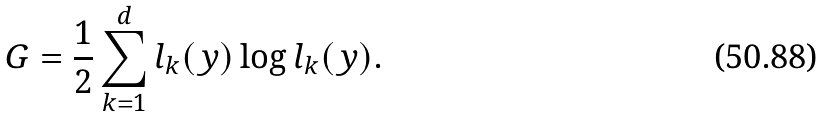Convert formula to latex. <formula><loc_0><loc_0><loc_500><loc_500>G = \frac { 1 } { 2 } \sum _ { k = 1 } ^ { d } l _ { k } ( y ) \log l _ { k } ( y ) .</formula> 